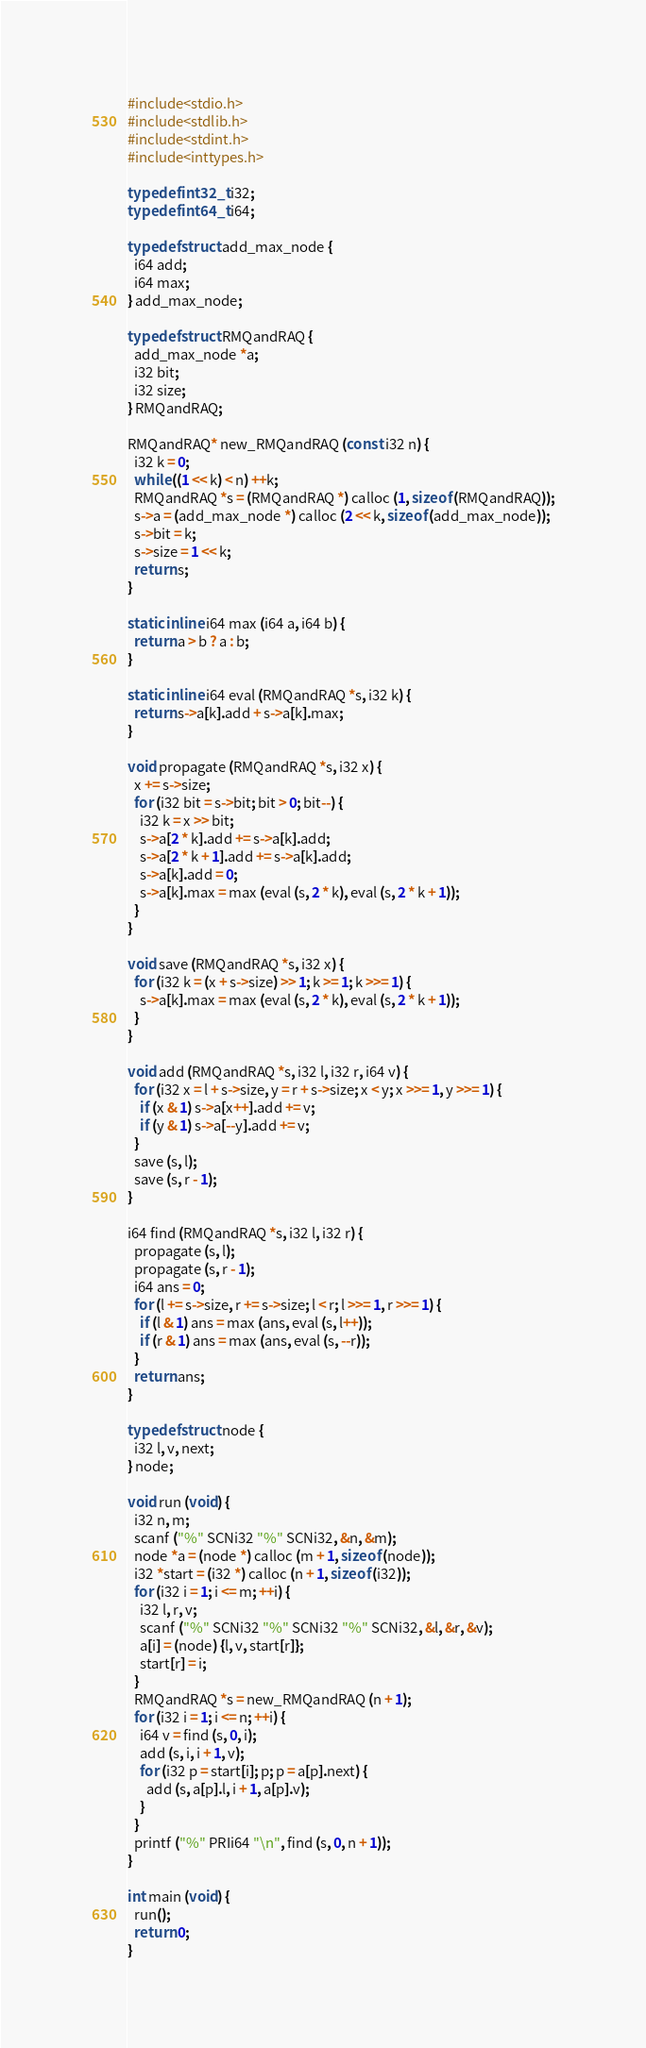Convert code to text. <code><loc_0><loc_0><loc_500><loc_500><_C_>#include<stdio.h>
#include<stdlib.h>
#include<stdint.h>
#include<inttypes.h>

typedef int32_t i32;
typedef int64_t i64;

typedef struct add_max_node {
  i64 add;
  i64 max;
} add_max_node;

typedef struct RMQandRAQ {
  add_max_node *a;
  i32 bit;
  i32 size;
} RMQandRAQ;

RMQandRAQ* new_RMQandRAQ (const i32 n) {
  i32 k = 0;
  while ((1 << k) < n) ++k;
  RMQandRAQ *s = (RMQandRAQ *) calloc (1, sizeof (RMQandRAQ));
  s->a = (add_max_node *) calloc (2 << k, sizeof (add_max_node));
  s->bit = k;
  s->size = 1 << k;
  return s;
}

static inline i64 max (i64 a, i64 b) {
  return a > b ? a : b;
}

static inline i64 eval (RMQandRAQ *s, i32 k) {
  return s->a[k].add + s->a[k].max;
}

void propagate (RMQandRAQ *s, i32 x) {
  x += s->size;
  for (i32 bit = s->bit; bit > 0; bit--) {
    i32 k = x >> bit;
    s->a[2 * k].add += s->a[k].add;
    s->a[2 * k + 1].add += s->a[k].add;
    s->a[k].add = 0;
    s->a[k].max = max (eval (s, 2 * k), eval (s, 2 * k + 1));
  }
}

void save (RMQandRAQ *s, i32 x) {
  for (i32 k = (x + s->size) >> 1; k >= 1; k >>= 1) {
    s->a[k].max = max (eval (s, 2 * k), eval (s, 2 * k + 1));
  }
}

void add (RMQandRAQ *s, i32 l, i32 r, i64 v) {
  for (i32 x = l + s->size, y = r + s->size; x < y; x >>= 1, y >>= 1) {
    if (x & 1) s->a[x++].add += v;
    if (y & 1) s->a[--y].add += v;
  }
  save (s, l);
  save (s, r - 1);
}

i64 find (RMQandRAQ *s, i32 l, i32 r) {
  propagate (s, l);
  propagate (s, r - 1);
  i64 ans = 0;
  for (l += s->size, r += s->size; l < r; l >>= 1, r >>= 1) {
    if (l & 1) ans = max (ans, eval (s, l++));
    if (r & 1) ans = max (ans, eval (s, --r));
  }
  return ans;
}

typedef struct node {
  i32 l, v, next;
} node;

void run (void) {
  i32 n, m;
  scanf ("%" SCNi32 "%" SCNi32, &n, &m);
  node *a = (node *) calloc (m + 1, sizeof (node));
  i32 *start = (i32 *) calloc (n + 1, sizeof (i32));
  for (i32 i = 1; i <= m; ++i) {
    i32 l, r, v;
    scanf ("%" SCNi32 "%" SCNi32 "%" SCNi32, &l, &r, &v);
    a[i] = (node) {l, v, start[r]};
    start[r] = i;
  }
  RMQandRAQ *s = new_RMQandRAQ (n + 1);
  for (i32 i = 1; i <= n; ++i) {
    i64 v = find (s, 0, i);
    add (s, i, i + 1, v);
    for (i32 p = start[i]; p; p = a[p].next) {
      add (s, a[p].l, i + 1, a[p].v);
    }
  }
  printf ("%" PRIi64 "\n", find (s, 0, n + 1));
}

int main (void) {
  run();
  return 0;
}
</code> 